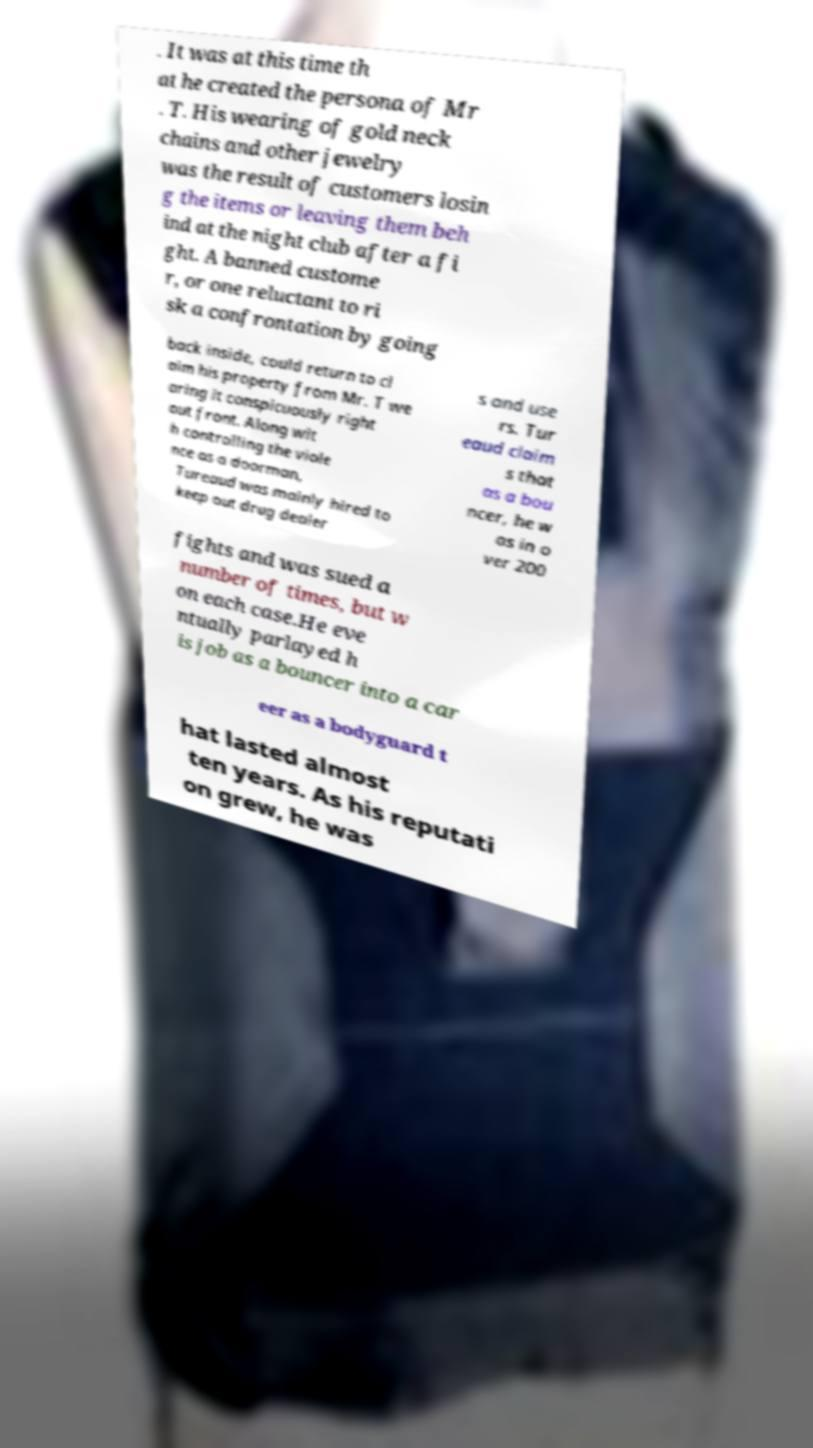I need the written content from this picture converted into text. Can you do that? . It was at this time th at he created the persona of Mr . T. His wearing of gold neck chains and other jewelry was the result of customers losin g the items or leaving them beh ind at the night club after a fi ght. A banned custome r, or one reluctant to ri sk a confrontation by going back inside, could return to cl aim his property from Mr. T we aring it conspicuously right out front. Along wit h controlling the viole nce as a doorman, Tureaud was mainly hired to keep out drug dealer s and use rs. Tur eaud claim s that as a bou ncer, he w as in o ver 200 fights and was sued a number of times, but w on each case.He eve ntually parlayed h is job as a bouncer into a car eer as a bodyguard t hat lasted almost ten years. As his reputati on grew, he was 